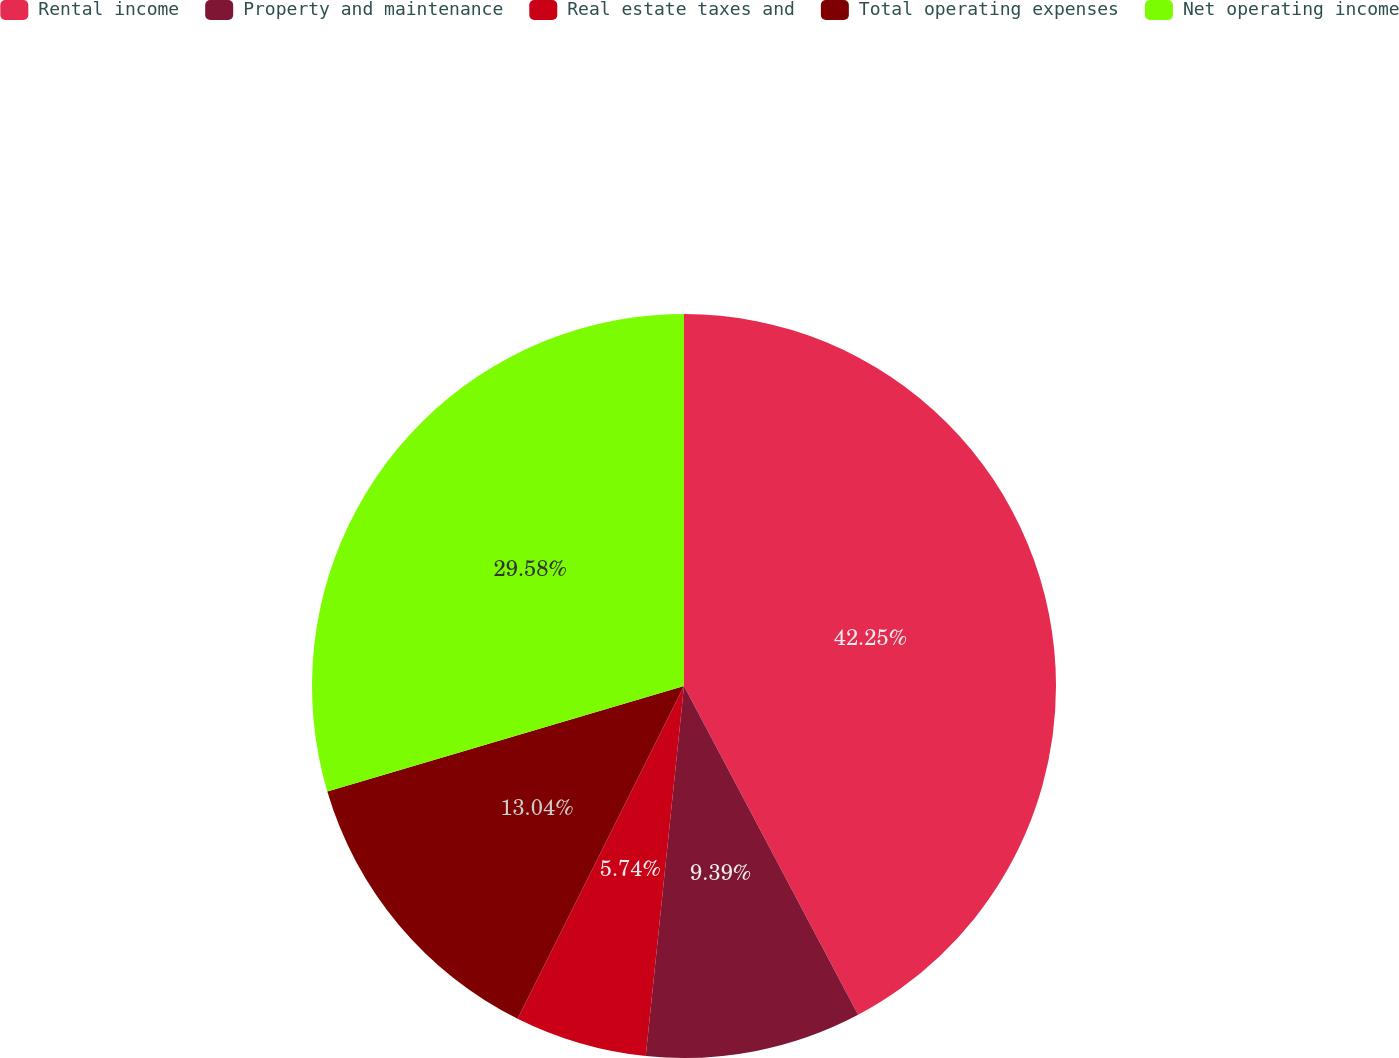<chart> <loc_0><loc_0><loc_500><loc_500><pie_chart><fcel>Rental income<fcel>Property and maintenance<fcel>Real estate taxes and<fcel>Total operating expenses<fcel>Net operating income<nl><fcel>42.25%<fcel>9.39%<fcel>5.74%<fcel>13.04%<fcel>29.58%<nl></chart> 